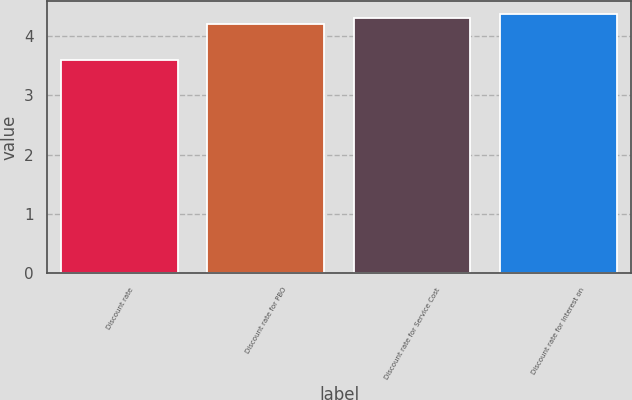Convert chart to OTSL. <chart><loc_0><loc_0><loc_500><loc_500><bar_chart><fcel>Discount rate<fcel>Discount rate for PBO<fcel>Discount rate for Service Cost<fcel>Discount rate for Interest on<nl><fcel>3.6<fcel>4.2<fcel>4.3<fcel>4.37<nl></chart> 